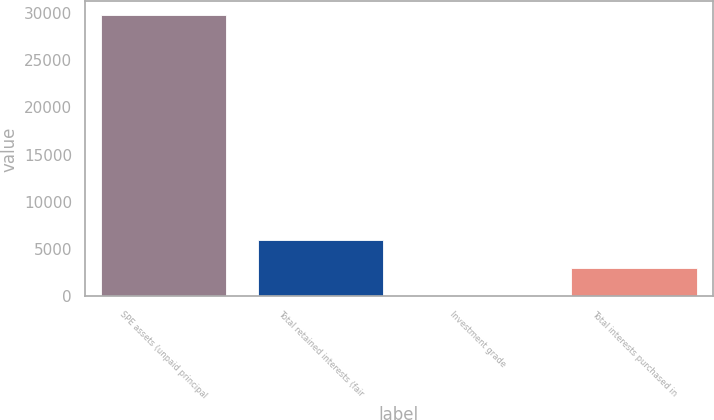<chart> <loc_0><loc_0><loc_500><loc_500><bar_chart><fcel>SPE assets (unpaid principal<fcel>Total retained interests (fair<fcel>Investment grade<fcel>Total interests purchased in<nl><fcel>29723<fcel>5955.8<fcel>14<fcel>2984.9<nl></chart> 